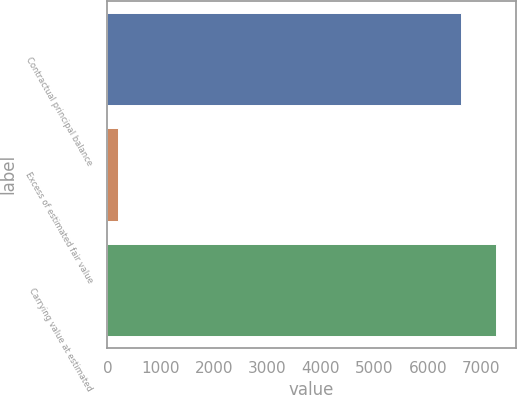Convert chart to OTSL. <chart><loc_0><loc_0><loc_500><loc_500><bar_chart><fcel>Contractual principal balance<fcel>Excess of estimated fair value<fcel>Carrying value at estimated<nl><fcel>6619<fcel>201<fcel>7280.9<nl></chart> 